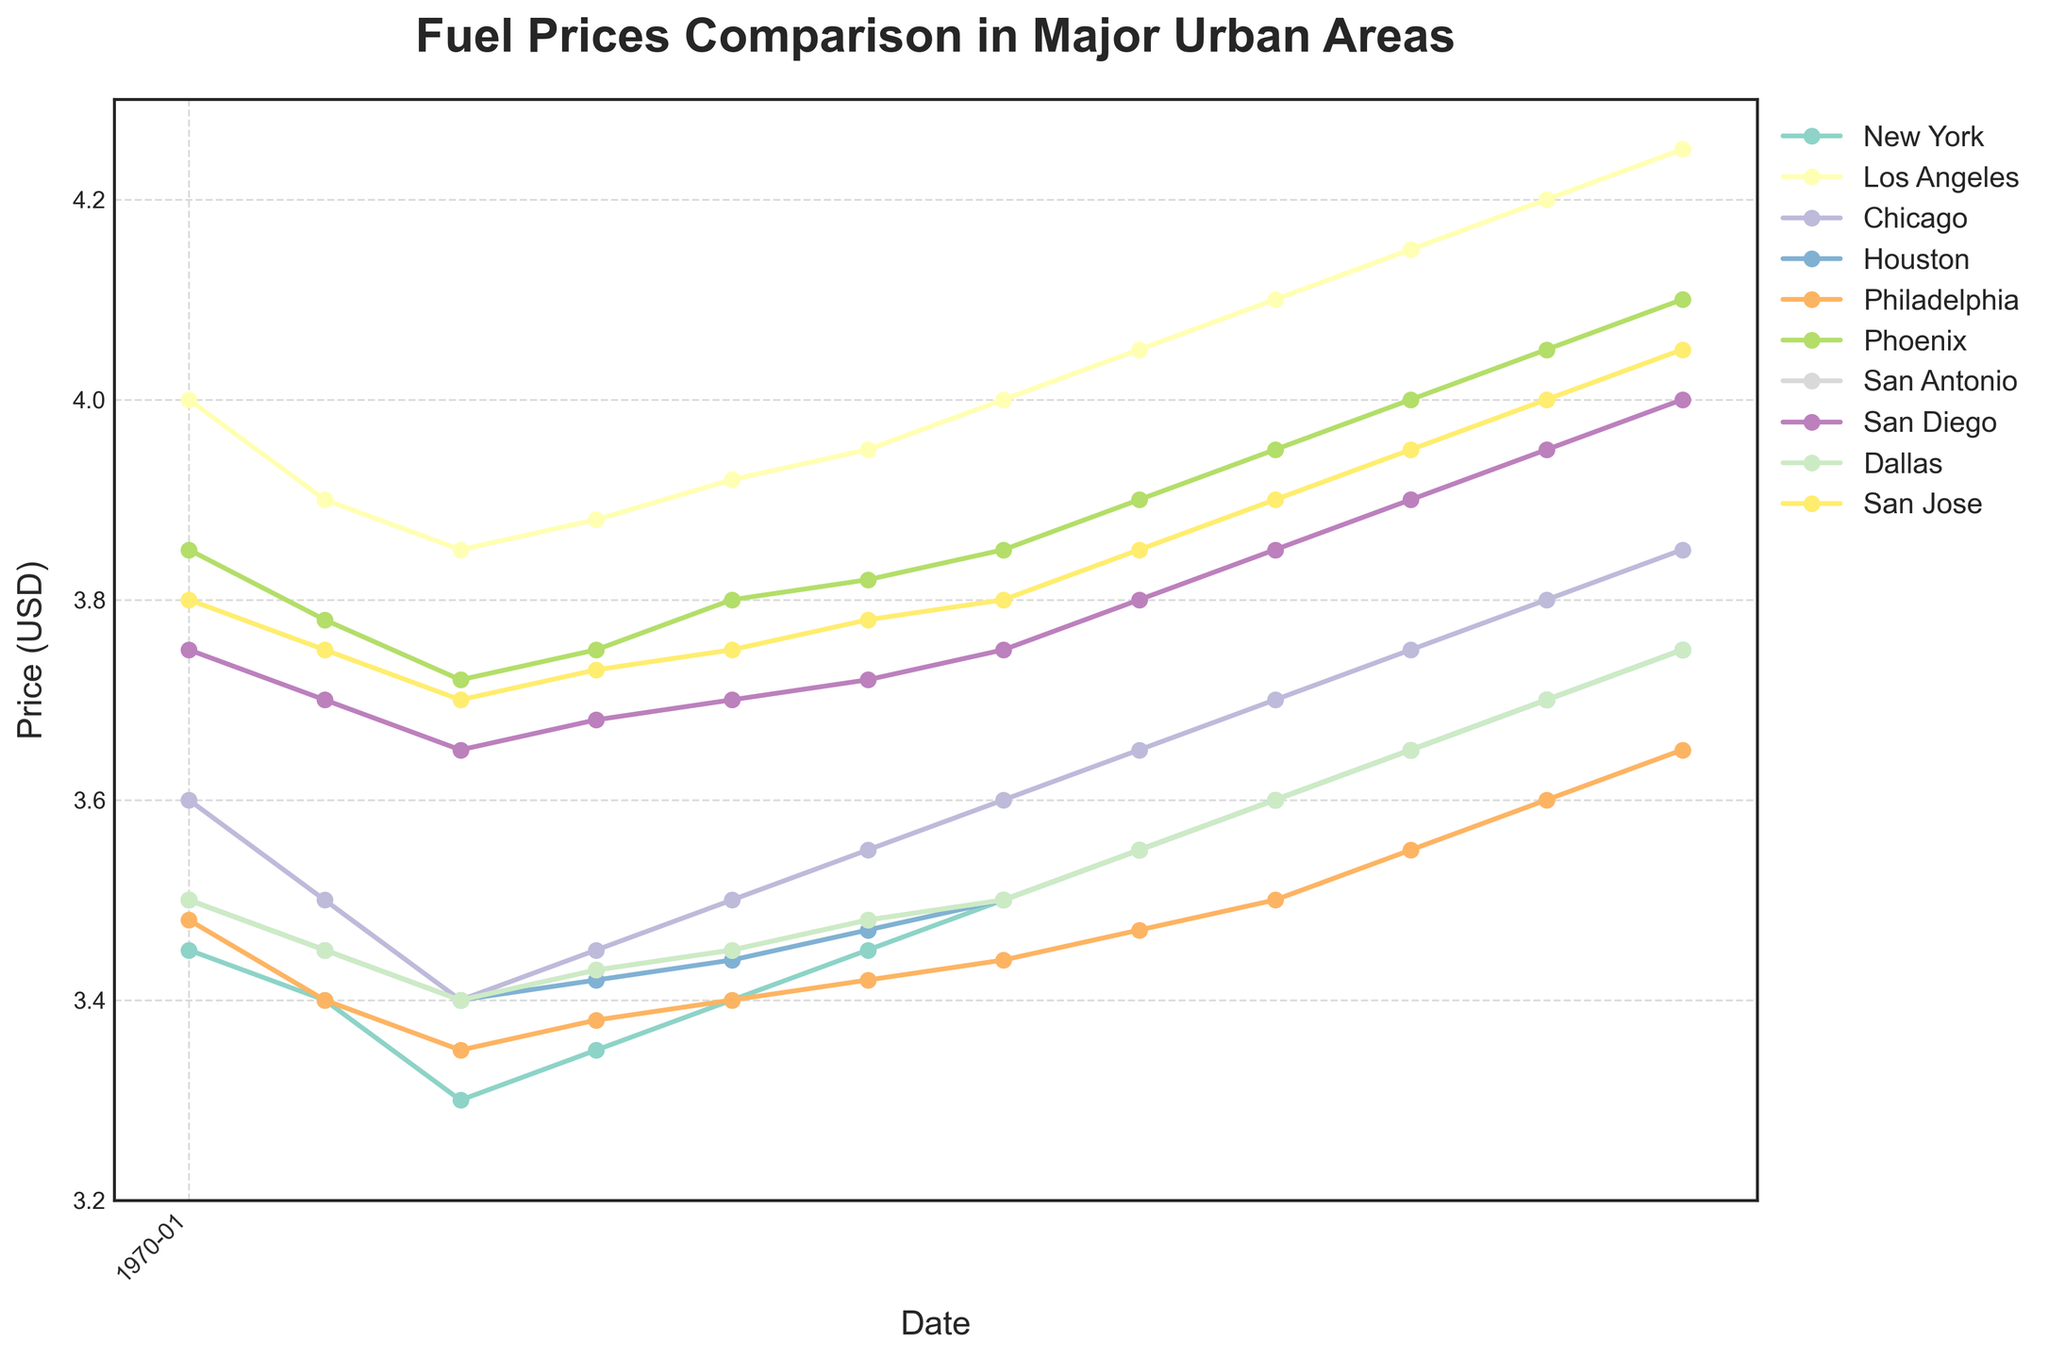What is the title of the plot? The title can be found at the top of the plot. It gives an overview of what the data is about.
Answer: Fuel Prices Comparison in Major Urban Areas Which city had the highest fuel price in September 2023? Looking at the plot, locate the fuel prices for all cities in September 2023 and identify the highest value.
Answer: Los Angeles What is the price range displayed on the y-axis? Observe the lowest and highest values on the y-axis to determine the range of prices.
Answer: 3.2 to 4.3 USD How many data points are plotted for each city? The x-axis represents the dates, and each marker corresponds to a data point. Count the number of markers along the timeline.
Answer: 12 Which city showed the most consistent fuel prices over the year? Examine the lines for each city and identify which one has the least fluctuations.
Answer: Philadelphia In which month did Phoenix first surpass a price of 4.00 USD? Trace the line corresponding to Phoenix and identify when it first crosses the 4.00 USD mark.
Answer: July 2023 Which city had the lowest fuel price in December 2022? Look at the data for December 2022 and find the city with the lowest value.
Answer: New York What is the average fuel price in Chicago from October 2022 to September 2023? Sum all the monthly prices for Chicago and divide by the number of months (12). (3.60 + 3.50 + 3.40 + 3.45 + 3.50 + 3.55 + 3.60 + 3.65 + 3.70 + 3.75 + 3.80 + 3.85)/12 = 3.5783
Answer: 3.58 USD Which city experienced the greatest increase in fuel price from October 2022 to September 2023? Calculate the difference between the prices in October 2022 and September 2023 for each city and identify the maximum difference.
Answer: San Diego Was there a month where all cities had the same fuel price? Review each month to see if there was any instance where all the lines converged to the same point.
Answer: No 